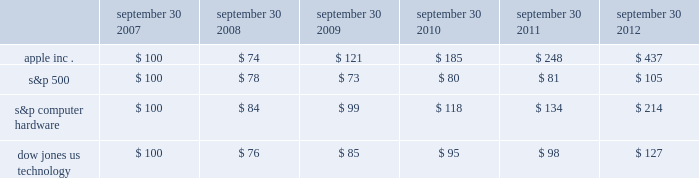Company stock performance the following graph shows a five-year comparison of cumulative total shareholder return , calculated on a dividend reinvested basis , for the company , the s&p 500 composite index , the s&p computer hardware index , and the dow jones u.s .
Technology index .
The graph assumes $ 100 was invested in each of the company 2019s common stock , the s&p 500 composite index , the s&p computer hardware index , and the dow jones u.s .
Technology index as of the market close on september 30 , 2007 .
Data points on the graph are annual .
Note that historic stock price performance is not necessarily indicative of future stock price performance .
Sep-11sep-10sep-09sep-08sep-07 sep-12 apple inc .
S&p 500 s&p computer hardware dow jones us technology comparison of 5 year cumulative total return* among apple inc. , the s&p 500 index , the s&p computer hardware index , and the dow jones us technology index *$ 100 invested on 9/30/07 in stock or index , including reinvestment of dividends .
Fiscal year ending september 30 .
Copyright a9 2012 s&p , a division of the mcgraw-hill companies inc .
All rights reserved .
September 30 , september 30 , september 30 , september 30 , september 30 , september 30 .

What was the cumulative total return on apple stock between september 30 2007 and september 30 2012? 
Computations: (437 - 100)
Answer: 337.0. 